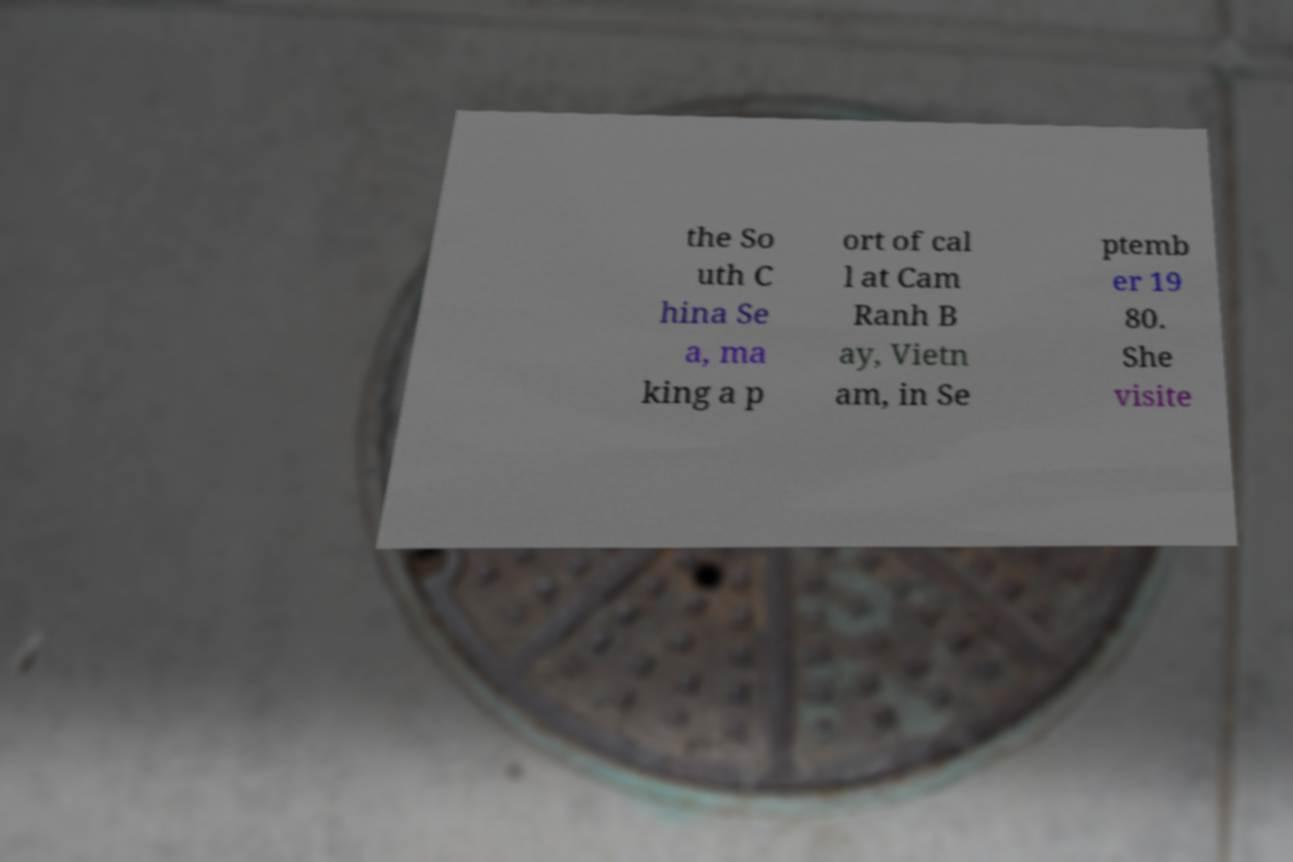There's text embedded in this image that I need extracted. Can you transcribe it verbatim? the So uth C hina Se a, ma king a p ort of cal l at Cam Ranh B ay, Vietn am, in Se ptemb er 19 80. She visite 